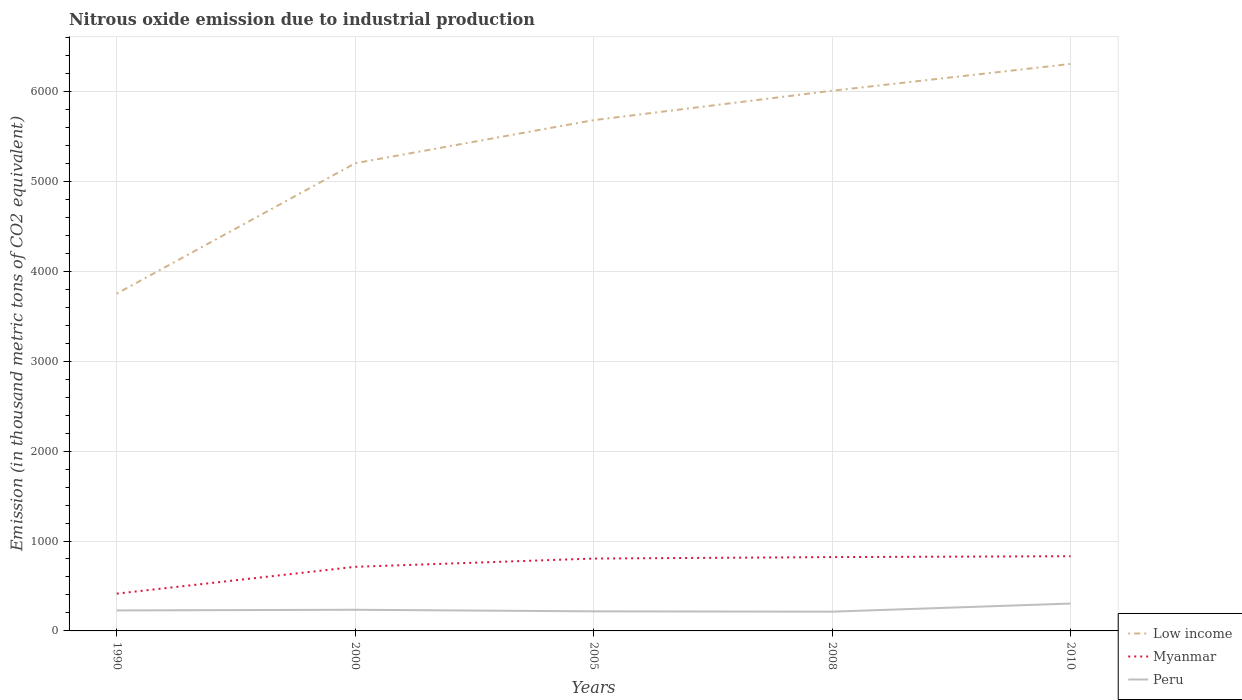Is the number of lines equal to the number of legend labels?
Give a very brief answer. Yes. Across all years, what is the maximum amount of nitrous oxide emitted in Peru?
Keep it short and to the point. 214.1. In which year was the amount of nitrous oxide emitted in Peru maximum?
Your answer should be very brief. 2008. What is the total amount of nitrous oxide emitted in Myanmar in the graph?
Make the answer very short. -416.1. What is the difference between the highest and the second highest amount of nitrous oxide emitted in Myanmar?
Give a very brief answer. 416.1. How many lines are there?
Provide a succinct answer. 3. Does the graph contain grids?
Your response must be concise. Yes. What is the title of the graph?
Offer a very short reply. Nitrous oxide emission due to industrial production. What is the label or title of the X-axis?
Make the answer very short. Years. What is the label or title of the Y-axis?
Make the answer very short. Emission (in thousand metric tons of CO2 equivalent). What is the Emission (in thousand metric tons of CO2 equivalent) in Low income in 1990?
Provide a succinct answer. 3751.3. What is the Emission (in thousand metric tons of CO2 equivalent) of Myanmar in 1990?
Your answer should be compact. 414.7. What is the Emission (in thousand metric tons of CO2 equivalent) of Peru in 1990?
Make the answer very short. 227.9. What is the Emission (in thousand metric tons of CO2 equivalent) of Low income in 2000?
Your answer should be compact. 5201.5. What is the Emission (in thousand metric tons of CO2 equivalent) in Myanmar in 2000?
Provide a short and direct response. 713.1. What is the Emission (in thousand metric tons of CO2 equivalent) in Peru in 2000?
Provide a short and direct response. 235.2. What is the Emission (in thousand metric tons of CO2 equivalent) of Low income in 2005?
Your answer should be very brief. 5680.8. What is the Emission (in thousand metric tons of CO2 equivalent) in Myanmar in 2005?
Offer a terse response. 804.8. What is the Emission (in thousand metric tons of CO2 equivalent) in Peru in 2005?
Keep it short and to the point. 217.8. What is the Emission (in thousand metric tons of CO2 equivalent) in Low income in 2008?
Your answer should be compact. 6007.5. What is the Emission (in thousand metric tons of CO2 equivalent) of Myanmar in 2008?
Make the answer very short. 821.1. What is the Emission (in thousand metric tons of CO2 equivalent) of Peru in 2008?
Ensure brevity in your answer.  214.1. What is the Emission (in thousand metric tons of CO2 equivalent) in Low income in 2010?
Provide a short and direct response. 6305.5. What is the Emission (in thousand metric tons of CO2 equivalent) of Myanmar in 2010?
Your answer should be compact. 830.8. What is the Emission (in thousand metric tons of CO2 equivalent) in Peru in 2010?
Your answer should be very brief. 304.4. Across all years, what is the maximum Emission (in thousand metric tons of CO2 equivalent) in Low income?
Your answer should be very brief. 6305.5. Across all years, what is the maximum Emission (in thousand metric tons of CO2 equivalent) in Myanmar?
Provide a short and direct response. 830.8. Across all years, what is the maximum Emission (in thousand metric tons of CO2 equivalent) of Peru?
Your answer should be compact. 304.4. Across all years, what is the minimum Emission (in thousand metric tons of CO2 equivalent) in Low income?
Ensure brevity in your answer.  3751.3. Across all years, what is the minimum Emission (in thousand metric tons of CO2 equivalent) of Myanmar?
Your answer should be compact. 414.7. Across all years, what is the minimum Emission (in thousand metric tons of CO2 equivalent) of Peru?
Make the answer very short. 214.1. What is the total Emission (in thousand metric tons of CO2 equivalent) of Low income in the graph?
Your answer should be very brief. 2.69e+04. What is the total Emission (in thousand metric tons of CO2 equivalent) of Myanmar in the graph?
Provide a short and direct response. 3584.5. What is the total Emission (in thousand metric tons of CO2 equivalent) of Peru in the graph?
Give a very brief answer. 1199.4. What is the difference between the Emission (in thousand metric tons of CO2 equivalent) in Low income in 1990 and that in 2000?
Give a very brief answer. -1450.2. What is the difference between the Emission (in thousand metric tons of CO2 equivalent) of Myanmar in 1990 and that in 2000?
Your response must be concise. -298.4. What is the difference between the Emission (in thousand metric tons of CO2 equivalent) of Peru in 1990 and that in 2000?
Your answer should be compact. -7.3. What is the difference between the Emission (in thousand metric tons of CO2 equivalent) of Low income in 1990 and that in 2005?
Your answer should be very brief. -1929.5. What is the difference between the Emission (in thousand metric tons of CO2 equivalent) in Myanmar in 1990 and that in 2005?
Your answer should be compact. -390.1. What is the difference between the Emission (in thousand metric tons of CO2 equivalent) of Low income in 1990 and that in 2008?
Offer a terse response. -2256.2. What is the difference between the Emission (in thousand metric tons of CO2 equivalent) in Myanmar in 1990 and that in 2008?
Make the answer very short. -406.4. What is the difference between the Emission (in thousand metric tons of CO2 equivalent) of Peru in 1990 and that in 2008?
Provide a short and direct response. 13.8. What is the difference between the Emission (in thousand metric tons of CO2 equivalent) of Low income in 1990 and that in 2010?
Ensure brevity in your answer.  -2554.2. What is the difference between the Emission (in thousand metric tons of CO2 equivalent) of Myanmar in 1990 and that in 2010?
Provide a succinct answer. -416.1. What is the difference between the Emission (in thousand metric tons of CO2 equivalent) in Peru in 1990 and that in 2010?
Offer a very short reply. -76.5. What is the difference between the Emission (in thousand metric tons of CO2 equivalent) in Low income in 2000 and that in 2005?
Provide a short and direct response. -479.3. What is the difference between the Emission (in thousand metric tons of CO2 equivalent) in Myanmar in 2000 and that in 2005?
Keep it short and to the point. -91.7. What is the difference between the Emission (in thousand metric tons of CO2 equivalent) in Peru in 2000 and that in 2005?
Your answer should be compact. 17.4. What is the difference between the Emission (in thousand metric tons of CO2 equivalent) in Low income in 2000 and that in 2008?
Provide a short and direct response. -806. What is the difference between the Emission (in thousand metric tons of CO2 equivalent) in Myanmar in 2000 and that in 2008?
Keep it short and to the point. -108. What is the difference between the Emission (in thousand metric tons of CO2 equivalent) in Peru in 2000 and that in 2008?
Keep it short and to the point. 21.1. What is the difference between the Emission (in thousand metric tons of CO2 equivalent) in Low income in 2000 and that in 2010?
Keep it short and to the point. -1104. What is the difference between the Emission (in thousand metric tons of CO2 equivalent) of Myanmar in 2000 and that in 2010?
Make the answer very short. -117.7. What is the difference between the Emission (in thousand metric tons of CO2 equivalent) of Peru in 2000 and that in 2010?
Offer a terse response. -69.2. What is the difference between the Emission (in thousand metric tons of CO2 equivalent) of Low income in 2005 and that in 2008?
Make the answer very short. -326.7. What is the difference between the Emission (in thousand metric tons of CO2 equivalent) of Myanmar in 2005 and that in 2008?
Provide a succinct answer. -16.3. What is the difference between the Emission (in thousand metric tons of CO2 equivalent) in Peru in 2005 and that in 2008?
Provide a short and direct response. 3.7. What is the difference between the Emission (in thousand metric tons of CO2 equivalent) in Low income in 2005 and that in 2010?
Offer a terse response. -624.7. What is the difference between the Emission (in thousand metric tons of CO2 equivalent) in Peru in 2005 and that in 2010?
Give a very brief answer. -86.6. What is the difference between the Emission (in thousand metric tons of CO2 equivalent) in Low income in 2008 and that in 2010?
Keep it short and to the point. -298. What is the difference between the Emission (in thousand metric tons of CO2 equivalent) of Peru in 2008 and that in 2010?
Ensure brevity in your answer.  -90.3. What is the difference between the Emission (in thousand metric tons of CO2 equivalent) in Low income in 1990 and the Emission (in thousand metric tons of CO2 equivalent) in Myanmar in 2000?
Keep it short and to the point. 3038.2. What is the difference between the Emission (in thousand metric tons of CO2 equivalent) of Low income in 1990 and the Emission (in thousand metric tons of CO2 equivalent) of Peru in 2000?
Provide a succinct answer. 3516.1. What is the difference between the Emission (in thousand metric tons of CO2 equivalent) in Myanmar in 1990 and the Emission (in thousand metric tons of CO2 equivalent) in Peru in 2000?
Provide a succinct answer. 179.5. What is the difference between the Emission (in thousand metric tons of CO2 equivalent) in Low income in 1990 and the Emission (in thousand metric tons of CO2 equivalent) in Myanmar in 2005?
Provide a short and direct response. 2946.5. What is the difference between the Emission (in thousand metric tons of CO2 equivalent) of Low income in 1990 and the Emission (in thousand metric tons of CO2 equivalent) of Peru in 2005?
Keep it short and to the point. 3533.5. What is the difference between the Emission (in thousand metric tons of CO2 equivalent) of Myanmar in 1990 and the Emission (in thousand metric tons of CO2 equivalent) of Peru in 2005?
Your answer should be very brief. 196.9. What is the difference between the Emission (in thousand metric tons of CO2 equivalent) in Low income in 1990 and the Emission (in thousand metric tons of CO2 equivalent) in Myanmar in 2008?
Offer a very short reply. 2930.2. What is the difference between the Emission (in thousand metric tons of CO2 equivalent) of Low income in 1990 and the Emission (in thousand metric tons of CO2 equivalent) of Peru in 2008?
Offer a very short reply. 3537.2. What is the difference between the Emission (in thousand metric tons of CO2 equivalent) in Myanmar in 1990 and the Emission (in thousand metric tons of CO2 equivalent) in Peru in 2008?
Offer a very short reply. 200.6. What is the difference between the Emission (in thousand metric tons of CO2 equivalent) of Low income in 1990 and the Emission (in thousand metric tons of CO2 equivalent) of Myanmar in 2010?
Keep it short and to the point. 2920.5. What is the difference between the Emission (in thousand metric tons of CO2 equivalent) of Low income in 1990 and the Emission (in thousand metric tons of CO2 equivalent) of Peru in 2010?
Your response must be concise. 3446.9. What is the difference between the Emission (in thousand metric tons of CO2 equivalent) of Myanmar in 1990 and the Emission (in thousand metric tons of CO2 equivalent) of Peru in 2010?
Keep it short and to the point. 110.3. What is the difference between the Emission (in thousand metric tons of CO2 equivalent) in Low income in 2000 and the Emission (in thousand metric tons of CO2 equivalent) in Myanmar in 2005?
Offer a terse response. 4396.7. What is the difference between the Emission (in thousand metric tons of CO2 equivalent) of Low income in 2000 and the Emission (in thousand metric tons of CO2 equivalent) of Peru in 2005?
Provide a succinct answer. 4983.7. What is the difference between the Emission (in thousand metric tons of CO2 equivalent) of Myanmar in 2000 and the Emission (in thousand metric tons of CO2 equivalent) of Peru in 2005?
Keep it short and to the point. 495.3. What is the difference between the Emission (in thousand metric tons of CO2 equivalent) in Low income in 2000 and the Emission (in thousand metric tons of CO2 equivalent) in Myanmar in 2008?
Provide a short and direct response. 4380.4. What is the difference between the Emission (in thousand metric tons of CO2 equivalent) of Low income in 2000 and the Emission (in thousand metric tons of CO2 equivalent) of Peru in 2008?
Provide a succinct answer. 4987.4. What is the difference between the Emission (in thousand metric tons of CO2 equivalent) of Myanmar in 2000 and the Emission (in thousand metric tons of CO2 equivalent) of Peru in 2008?
Give a very brief answer. 499. What is the difference between the Emission (in thousand metric tons of CO2 equivalent) of Low income in 2000 and the Emission (in thousand metric tons of CO2 equivalent) of Myanmar in 2010?
Your response must be concise. 4370.7. What is the difference between the Emission (in thousand metric tons of CO2 equivalent) of Low income in 2000 and the Emission (in thousand metric tons of CO2 equivalent) of Peru in 2010?
Keep it short and to the point. 4897.1. What is the difference between the Emission (in thousand metric tons of CO2 equivalent) of Myanmar in 2000 and the Emission (in thousand metric tons of CO2 equivalent) of Peru in 2010?
Provide a short and direct response. 408.7. What is the difference between the Emission (in thousand metric tons of CO2 equivalent) in Low income in 2005 and the Emission (in thousand metric tons of CO2 equivalent) in Myanmar in 2008?
Give a very brief answer. 4859.7. What is the difference between the Emission (in thousand metric tons of CO2 equivalent) of Low income in 2005 and the Emission (in thousand metric tons of CO2 equivalent) of Peru in 2008?
Offer a very short reply. 5466.7. What is the difference between the Emission (in thousand metric tons of CO2 equivalent) of Myanmar in 2005 and the Emission (in thousand metric tons of CO2 equivalent) of Peru in 2008?
Keep it short and to the point. 590.7. What is the difference between the Emission (in thousand metric tons of CO2 equivalent) in Low income in 2005 and the Emission (in thousand metric tons of CO2 equivalent) in Myanmar in 2010?
Offer a terse response. 4850. What is the difference between the Emission (in thousand metric tons of CO2 equivalent) in Low income in 2005 and the Emission (in thousand metric tons of CO2 equivalent) in Peru in 2010?
Your answer should be very brief. 5376.4. What is the difference between the Emission (in thousand metric tons of CO2 equivalent) of Myanmar in 2005 and the Emission (in thousand metric tons of CO2 equivalent) of Peru in 2010?
Make the answer very short. 500.4. What is the difference between the Emission (in thousand metric tons of CO2 equivalent) of Low income in 2008 and the Emission (in thousand metric tons of CO2 equivalent) of Myanmar in 2010?
Your answer should be compact. 5176.7. What is the difference between the Emission (in thousand metric tons of CO2 equivalent) of Low income in 2008 and the Emission (in thousand metric tons of CO2 equivalent) of Peru in 2010?
Your response must be concise. 5703.1. What is the difference between the Emission (in thousand metric tons of CO2 equivalent) in Myanmar in 2008 and the Emission (in thousand metric tons of CO2 equivalent) in Peru in 2010?
Offer a very short reply. 516.7. What is the average Emission (in thousand metric tons of CO2 equivalent) of Low income per year?
Make the answer very short. 5389.32. What is the average Emission (in thousand metric tons of CO2 equivalent) of Myanmar per year?
Ensure brevity in your answer.  716.9. What is the average Emission (in thousand metric tons of CO2 equivalent) in Peru per year?
Ensure brevity in your answer.  239.88. In the year 1990, what is the difference between the Emission (in thousand metric tons of CO2 equivalent) in Low income and Emission (in thousand metric tons of CO2 equivalent) in Myanmar?
Offer a terse response. 3336.6. In the year 1990, what is the difference between the Emission (in thousand metric tons of CO2 equivalent) of Low income and Emission (in thousand metric tons of CO2 equivalent) of Peru?
Provide a succinct answer. 3523.4. In the year 1990, what is the difference between the Emission (in thousand metric tons of CO2 equivalent) in Myanmar and Emission (in thousand metric tons of CO2 equivalent) in Peru?
Offer a terse response. 186.8. In the year 2000, what is the difference between the Emission (in thousand metric tons of CO2 equivalent) in Low income and Emission (in thousand metric tons of CO2 equivalent) in Myanmar?
Your response must be concise. 4488.4. In the year 2000, what is the difference between the Emission (in thousand metric tons of CO2 equivalent) of Low income and Emission (in thousand metric tons of CO2 equivalent) of Peru?
Your answer should be compact. 4966.3. In the year 2000, what is the difference between the Emission (in thousand metric tons of CO2 equivalent) in Myanmar and Emission (in thousand metric tons of CO2 equivalent) in Peru?
Make the answer very short. 477.9. In the year 2005, what is the difference between the Emission (in thousand metric tons of CO2 equivalent) in Low income and Emission (in thousand metric tons of CO2 equivalent) in Myanmar?
Give a very brief answer. 4876. In the year 2005, what is the difference between the Emission (in thousand metric tons of CO2 equivalent) of Low income and Emission (in thousand metric tons of CO2 equivalent) of Peru?
Your answer should be compact. 5463. In the year 2005, what is the difference between the Emission (in thousand metric tons of CO2 equivalent) of Myanmar and Emission (in thousand metric tons of CO2 equivalent) of Peru?
Offer a very short reply. 587. In the year 2008, what is the difference between the Emission (in thousand metric tons of CO2 equivalent) in Low income and Emission (in thousand metric tons of CO2 equivalent) in Myanmar?
Offer a terse response. 5186.4. In the year 2008, what is the difference between the Emission (in thousand metric tons of CO2 equivalent) of Low income and Emission (in thousand metric tons of CO2 equivalent) of Peru?
Give a very brief answer. 5793.4. In the year 2008, what is the difference between the Emission (in thousand metric tons of CO2 equivalent) of Myanmar and Emission (in thousand metric tons of CO2 equivalent) of Peru?
Ensure brevity in your answer.  607. In the year 2010, what is the difference between the Emission (in thousand metric tons of CO2 equivalent) in Low income and Emission (in thousand metric tons of CO2 equivalent) in Myanmar?
Keep it short and to the point. 5474.7. In the year 2010, what is the difference between the Emission (in thousand metric tons of CO2 equivalent) in Low income and Emission (in thousand metric tons of CO2 equivalent) in Peru?
Keep it short and to the point. 6001.1. In the year 2010, what is the difference between the Emission (in thousand metric tons of CO2 equivalent) of Myanmar and Emission (in thousand metric tons of CO2 equivalent) of Peru?
Your answer should be compact. 526.4. What is the ratio of the Emission (in thousand metric tons of CO2 equivalent) in Low income in 1990 to that in 2000?
Provide a short and direct response. 0.72. What is the ratio of the Emission (in thousand metric tons of CO2 equivalent) in Myanmar in 1990 to that in 2000?
Keep it short and to the point. 0.58. What is the ratio of the Emission (in thousand metric tons of CO2 equivalent) of Peru in 1990 to that in 2000?
Offer a very short reply. 0.97. What is the ratio of the Emission (in thousand metric tons of CO2 equivalent) in Low income in 1990 to that in 2005?
Offer a terse response. 0.66. What is the ratio of the Emission (in thousand metric tons of CO2 equivalent) of Myanmar in 1990 to that in 2005?
Make the answer very short. 0.52. What is the ratio of the Emission (in thousand metric tons of CO2 equivalent) in Peru in 1990 to that in 2005?
Give a very brief answer. 1.05. What is the ratio of the Emission (in thousand metric tons of CO2 equivalent) in Low income in 1990 to that in 2008?
Provide a short and direct response. 0.62. What is the ratio of the Emission (in thousand metric tons of CO2 equivalent) in Myanmar in 1990 to that in 2008?
Provide a succinct answer. 0.51. What is the ratio of the Emission (in thousand metric tons of CO2 equivalent) of Peru in 1990 to that in 2008?
Make the answer very short. 1.06. What is the ratio of the Emission (in thousand metric tons of CO2 equivalent) in Low income in 1990 to that in 2010?
Make the answer very short. 0.59. What is the ratio of the Emission (in thousand metric tons of CO2 equivalent) of Myanmar in 1990 to that in 2010?
Make the answer very short. 0.5. What is the ratio of the Emission (in thousand metric tons of CO2 equivalent) of Peru in 1990 to that in 2010?
Your answer should be compact. 0.75. What is the ratio of the Emission (in thousand metric tons of CO2 equivalent) of Low income in 2000 to that in 2005?
Give a very brief answer. 0.92. What is the ratio of the Emission (in thousand metric tons of CO2 equivalent) of Myanmar in 2000 to that in 2005?
Provide a short and direct response. 0.89. What is the ratio of the Emission (in thousand metric tons of CO2 equivalent) of Peru in 2000 to that in 2005?
Your answer should be very brief. 1.08. What is the ratio of the Emission (in thousand metric tons of CO2 equivalent) in Low income in 2000 to that in 2008?
Make the answer very short. 0.87. What is the ratio of the Emission (in thousand metric tons of CO2 equivalent) of Myanmar in 2000 to that in 2008?
Provide a succinct answer. 0.87. What is the ratio of the Emission (in thousand metric tons of CO2 equivalent) of Peru in 2000 to that in 2008?
Give a very brief answer. 1.1. What is the ratio of the Emission (in thousand metric tons of CO2 equivalent) of Low income in 2000 to that in 2010?
Provide a succinct answer. 0.82. What is the ratio of the Emission (in thousand metric tons of CO2 equivalent) in Myanmar in 2000 to that in 2010?
Ensure brevity in your answer.  0.86. What is the ratio of the Emission (in thousand metric tons of CO2 equivalent) of Peru in 2000 to that in 2010?
Ensure brevity in your answer.  0.77. What is the ratio of the Emission (in thousand metric tons of CO2 equivalent) in Low income in 2005 to that in 2008?
Offer a terse response. 0.95. What is the ratio of the Emission (in thousand metric tons of CO2 equivalent) in Myanmar in 2005 to that in 2008?
Your response must be concise. 0.98. What is the ratio of the Emission (in thousand metric tons of CO2 equivalent) in Peru in 2005 to that in 2008?
Give a very brief answer. 1.02. What is the ratio of the Emission (in thousand metric tons of CO2 equivalent) of Low income in 2005 to that in 2010?
Provide a short and direct response. 0.9. What is the ratio of the Emission (in thousand metric tons of CO2 equivalent) in Myanmar in 2005 to that in 2010?
Ensure brevity in your answer.  0.97. What is the ratio of the Emission (in thousand metric tons of CO2 equivalent) in Peru in 2005 to that in 2010?
Offer a very short reply. 0.72. What is the ratio of the Emission (in thousand metric tons of CO2 equivalent) in Low income in 2008 to that in 2010?
Make the answer very short. 0.95. What is the ratio of the Emission (in thousand metric tons of CO2 equivalent) in Myanmar in 2008 to that in 2010?
Make the answer very short. 0.99. What is the ratio of the Emission (in thousand metric tons of CO2 equivalent) in Peru in 2008 to that in 2010?
Offer a very short reply. 0.7. What is the difference between the highest and the second highest Emission (in thousand metric tons of CO2 equivalent) in Low income?
Provide a short and direct response. 298. What is the difference between the highest and the second highest Emission (in thousand metric tons of CO2 equivalent) of Peru?
Your response must be concise. 69.2. What is the difference between the highest and the lowest Emission (in thousand metric tons of CO2 equivalent) of Low income?
Provide a short and direct response. 2554.2. What is the difference between the highest and the lowest Emission (in thousand metric tons of CO2 equivalent) in Myanmar?
Ensure brevity in your answer.  416.1. What is the difference between the highest and the lowest Emission (in thousand metric tons of CO2 equivalent) of Peru?
Ensure brevity in your answer.  90.3. 